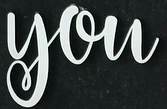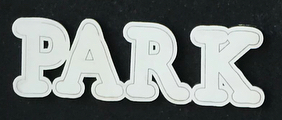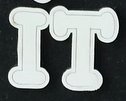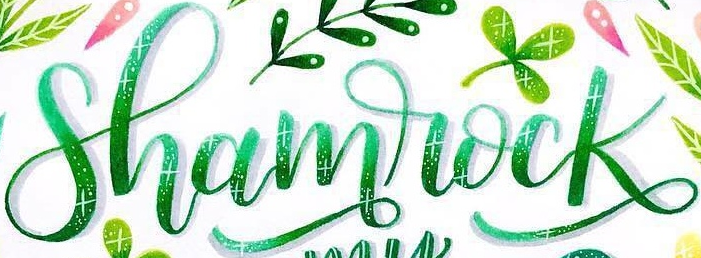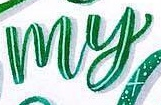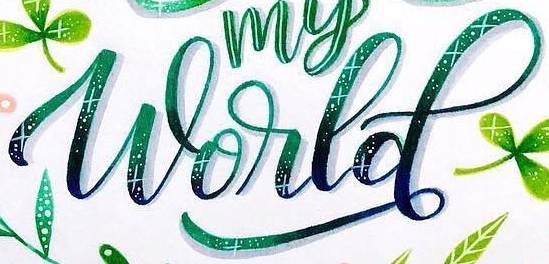Identify the words shown in these images in order, separated by a semicolon. you; PARK; IT; Shamrock; my; World 